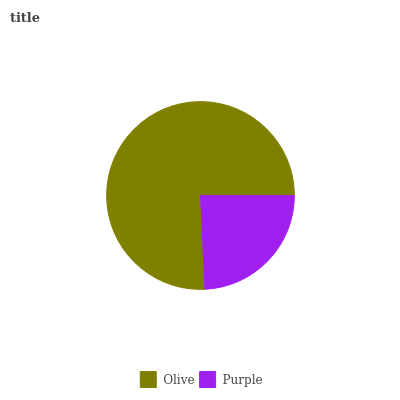Is Purple the minimum?
Answer yes or no. Yes. Is Olive the maximum?
Answer yes or no. Yes. Is Purple the maximum?
Answer yes or no. No. Is Olive greater than Purple?
Answer yes or no. Yes. Is Purple less than Olive?
Answer yes or no. Yes. Is Purple greater than Olive?
Answer yes or no. No. Is Olive less than Purple?
Answer yes or no. No. Is Olive the high median?
Answer yes or no. Yes. Is Purple the low median?
Answer yes or no. Yes. Is Purple the high median?
Answer yes or no. No. Is Olive the low median?
Answer yes or no. No. 